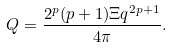<formula> <loc_0><loc_0><loc_500><loc_500>Q = \frac { 2 ^ { p } ( p + 1 ) \Xi q ^ { 2 p + 1 } } { 4 \pi } .</formula> 